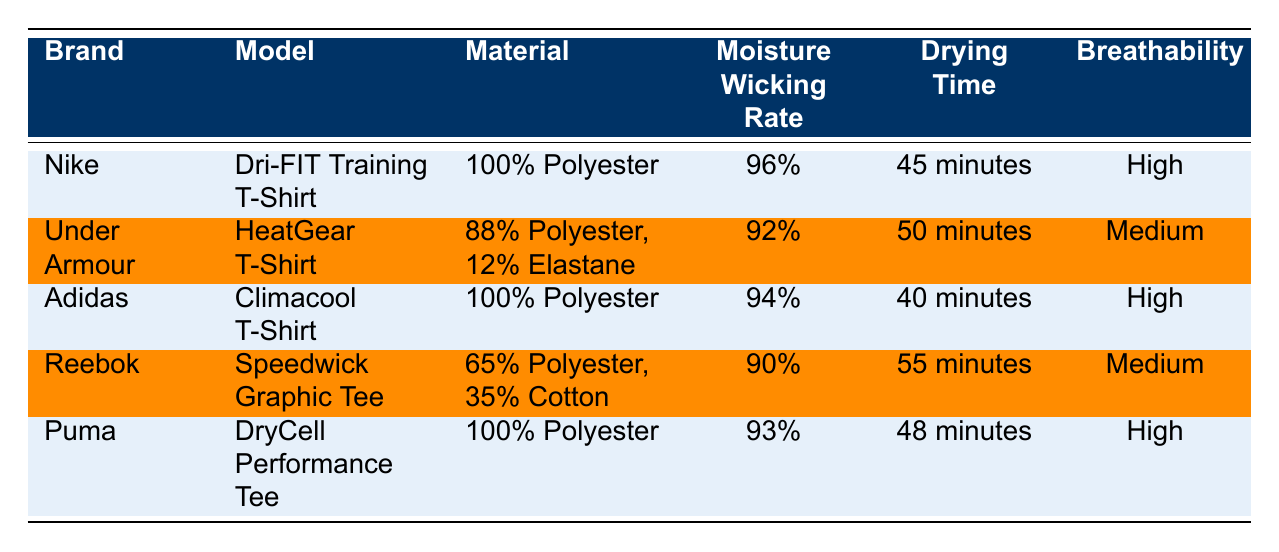What is the moisture wicking rate of the Nike Dri-FIT Training T-Shirt? The table shows that the moisture wicking rate for the Nike Dri-FIT Training T-Shirt is listed directly next to its model, which is 96%.
Answer: 96% How long does it take for the Adidas Climacool T-Shirt to dry? Referring to the table, the drying time for the Adidas Climacool T-Shirt is given as 40 minutes.
Answer: 40 minutes Is the material of the Under Armour HeatGear T-Shirt made solely of polyester? The table indicates that the Under Armour HeatGear T-Shirt is made of 88% Polyester and 12% Elastane, which means it is not solely made of polyester.
Answer: No Which apparel has the highest moisture wicking rate? By comparing the moisture wicking rates from the table, the Nike Dri-FIT Training T-Shirt at 96% has the highest rate when compared to others.
Answer: Nike Dri-FIT Training T-Shirt What is the average drying time of the clothes listed in the table? To find the average drying time, we first convert the drying times to minutes: 45 + 50 + 40 + 55 + 48 = 238 minutes. Then, we divide this total by the number of items (5): 238/5 = 47.6 minutes.
Answer: 47.6 minutes Does the Puma DryCell Performance Tee have a higher moisture wicking rate than the Reebok Speedwick Graphic Tee? Looking at the table, Puma’s moisture wicking rate is 93%, while Reebok’s is 90%. Since 93% is greater than 90%, Puma has a higher rate.
Answer: Yes What is the most breathable apparel listed in the table? The table shows that both the Nike Dri-FIT Training T-Shirt, Adidas Climacool T-Shirt, and Puma DryCell Performance Tee have 'High' breathability ratings, indicating they are the most breathable.
Answer: Nike Dri-FIT, Adidas Climacool, and Puma DryCell Which brand takes the longest to dry? By examining the drying times in the table, the longest drying time is for the Reebok Speedwick Graphic Tee, which takes 55 minutes.
Answer: Reebok Speedwick Graphic Tee What is the difference in moisture wicking rates between the Nike Dri-FIT and Under Armour HeatGear products? The moisture wicking rate for the Nike Dri-FIT is 96% and for the Under Armour HeatGear, it is 92%. The difference is calculated as 96% - 92% = 4%.
Answer: 4% 